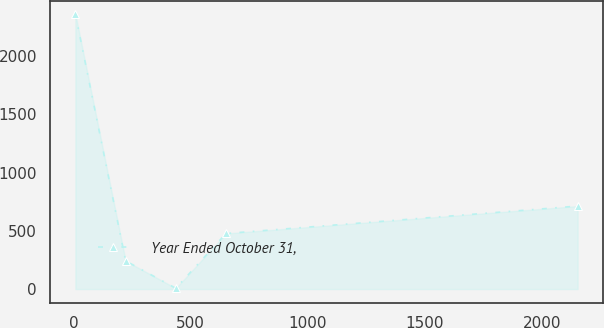<chart> <loc_0><loc_0><loc_500><loc_500><line_chart><ecel><fcel>Year Ended October 31,<nl><fcel>8.5<fcel>2359.68<nl><fcel>222.86<fcel>241.9<nl><fcel>437.22<fcel>6.59<nl><fcel>651.58<fcel>477.21<nl><fcel>2152.14<fcel>712.52<nl></chart> 